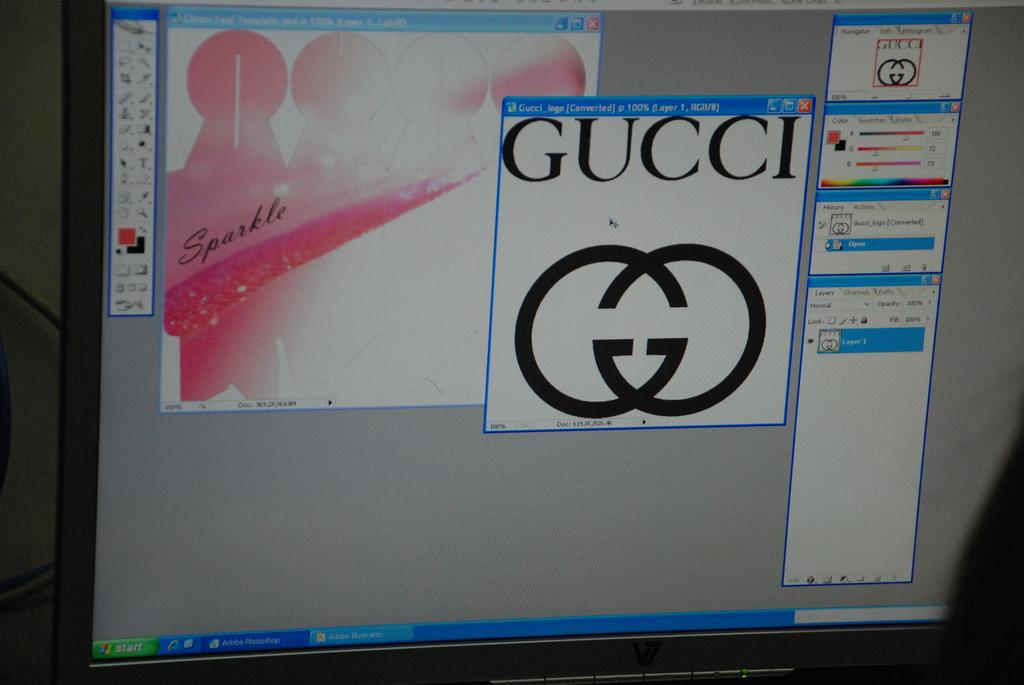<image>
Summarize the visual content of the image. a workspace with a document of the gucci logo open on it 